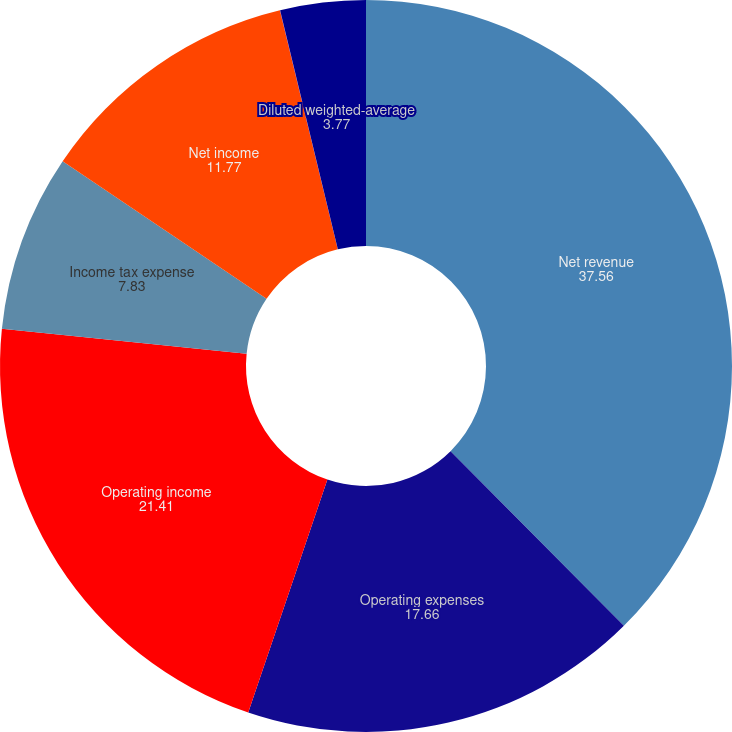Convert chart to OTSL. <chart><loc_0><loc_0><loc_500><loc_500><pie_chart><fcel>Net revenue<fcel>Operating expenses<fcel>Operating income<fcel>Income tax expense<fcel>Net income<fcel>Diluted earnings per share<fcel>Diluted weighted-average<nl><fcel>37.56%<fcel>17.66%<fcel>21.41%<fcel>7.83%<fcel>11.77%<fcel>0.01%<fcel>3.77%<nl></chart> 